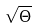Convert formula to latex. <formula><loc_0><loc_0><loc_500><loc_500>\sqrt { \Theta }</formula> 